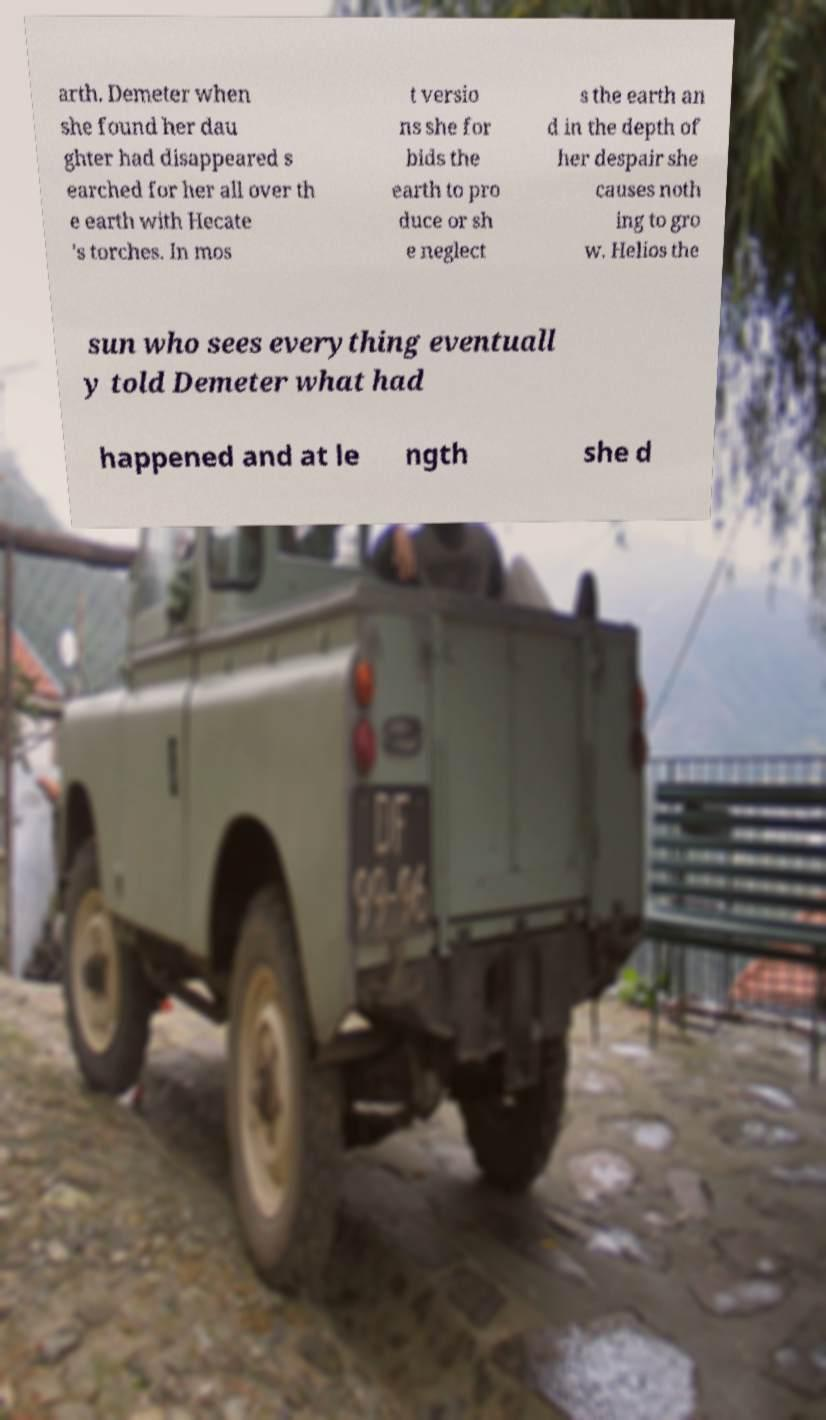There's text embedded in this image that I need extracted. Can you transcribe it verbatim? arth. Demeter when she found her dau ghter had disappeared s earched for her all over th e earth with Hecate 's torches. In mos t versio ns she for bids the earth to pro duce or sh e neglect s the earth an d in the depth of her despair she causes noth ing to gro w. Helios the sun who sees everything eventuall y told Demeter what had happened and at le ngth she d 